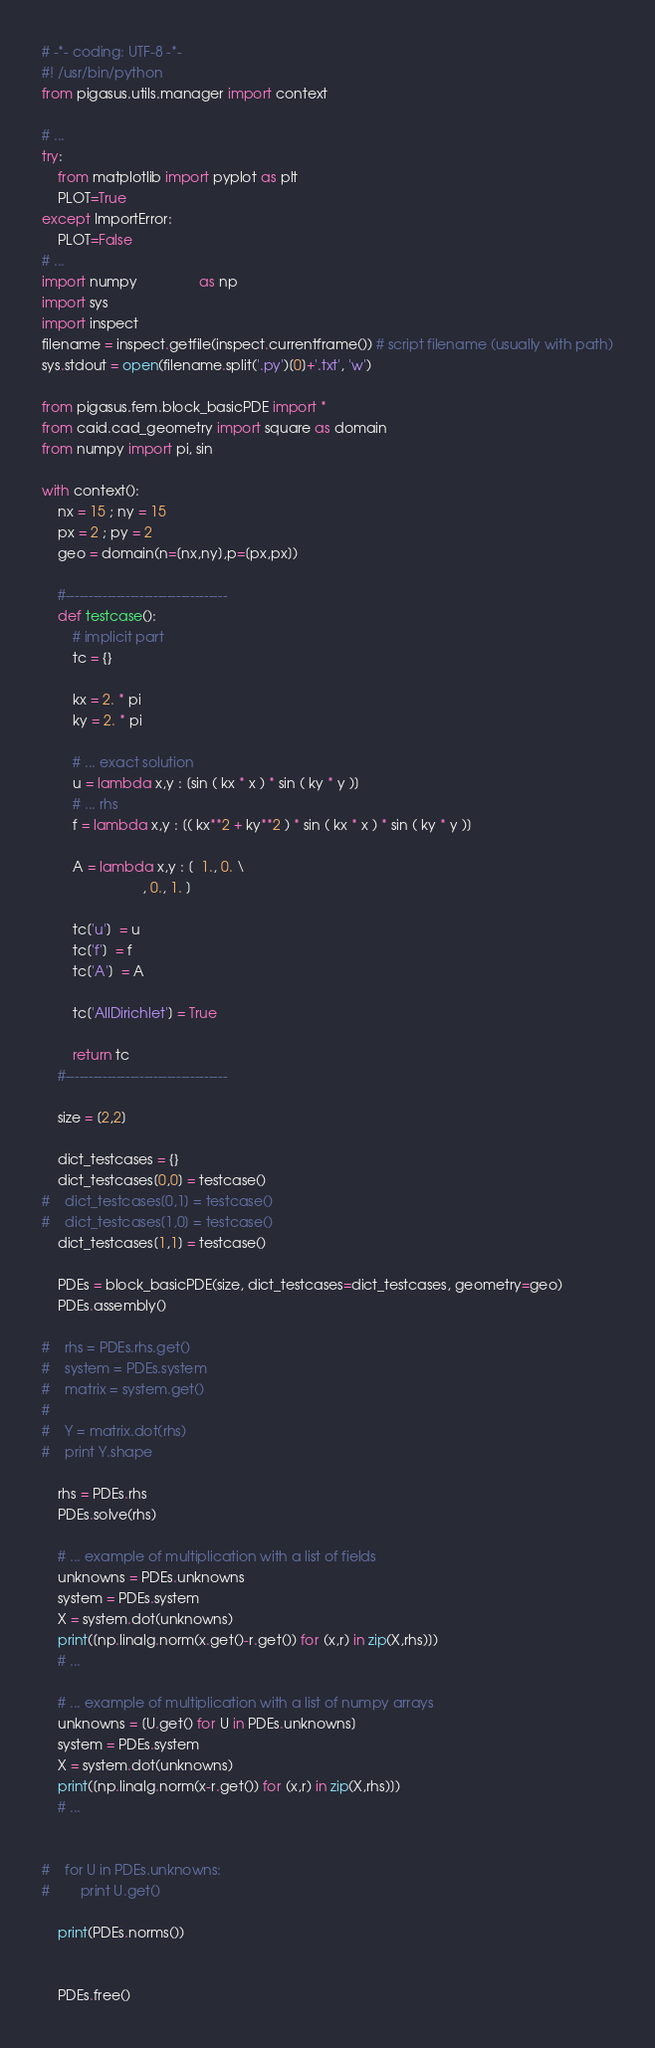<code> <loc_0><loc_0><loc_500><loc_500><_Python_># -*- coding: UTF-8 -*-
#! /usr/bin/python
from pigasus.utils.manager import context

# ...
try:
    from matplotlib import pyplot as plt
    PLOT=True
except ImportError:
    PLOT=False
# ...
import numpy                as np
import sys
import inspect
filename = inspect.getfile(inspect.currentframe()) # script filename (usually with path)
sys.stdout = open(filename.split('.py')[0]+'.txt', 'w')

from pigasus.fem.block_basicPDE import *
from caid.cad_geometry import square as domain
from numpy import pi, sin

with context():
    nx = 15 ; ny = 15
    px = 2 ; py = 2
    geo = domain(n=[nx,ny],p=[px,px])

    #-----------------------------------
    def testcase():
        # implicit part
        tc = {}

        kx = 2. * pi
        ky = 2. * pi

        # ... exact solution
        u = lambda x,y : [sin ( kx * x ) * sin ( ky * y )]
        # ... rhs
        f = lambda x,y : [( kx**2 + ky**2 ) * sin ( kx * x ) * sin ( ky * y )]

        A = lambda x,y : [  1., 0. \
                          , 0., 1. ]

        tc['u']  = u
        tc['f']  = f
        tc['A']  = A

        tc['AllDirichlet'] = True

        return tc
    #-----------------------------------

    size = [2,2]

    dict_testcases = {}
    dict_testcases[0,0] = testcase()
#    dict_testcases[0,1] = testcase()
#    dict_testcases[1,0] = testcase()
    dict_testcases[1,1] = testcase()

    PDEs = block_basicPDE(size, dict_testcases=dict_testcases, geometry=geo)
    PDEs.assembly()

#    rhs = PDEs.rhs.get()
#    system = PDEs.system
#    matrix = system.get()
#
#    Y = matrix.dot(rhs)
#    print Y.shape

    rhs = PDEs.rhs
    PDEs.solve(rhs)

    # ... example of multiplication with a list of fields
    unknowns = PDEs.unknowns
    system = PDEs.system
    X = system.dot(unknowns)
    print([np.linalg.norm(x.get()-r.get()) for (x,r) in zip(X,rhs)])
    # ...

    # ... example of multiplication with a list of numpy arrays
    unknowns = [U.get() for U in PDEs.unknowns]
    system = PDEs.system
    X = system.dot(unknowns)
    print([np.linalg.norm(x-r.get()) for (x,r) in zip(X,rhs)])
    # ...


#    for U in PDEs.unknowns:
#        print U.get()

    print(PDEs.norms())


    PDEs.free()
</code> 